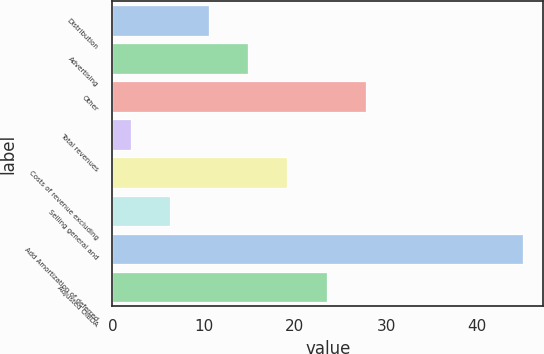<chart> <loc_0><loc_0><loc_500><loc_500><bar_chart><fcel>Distribution<fcel>Advertising<fcel>Other<fcel>Total revenues<fcel>Costs of revenue excluding<fcel>Selling general and<fcel>Add Amortization of deferred<fcel>Adjusted OIBDA<nl><fcel>10.6<fcel>14.9<fcel>27.8<fcel>2<fcel>19.2<fcel>6.3<fcel>45<fcel>23.5<nl></chart> 